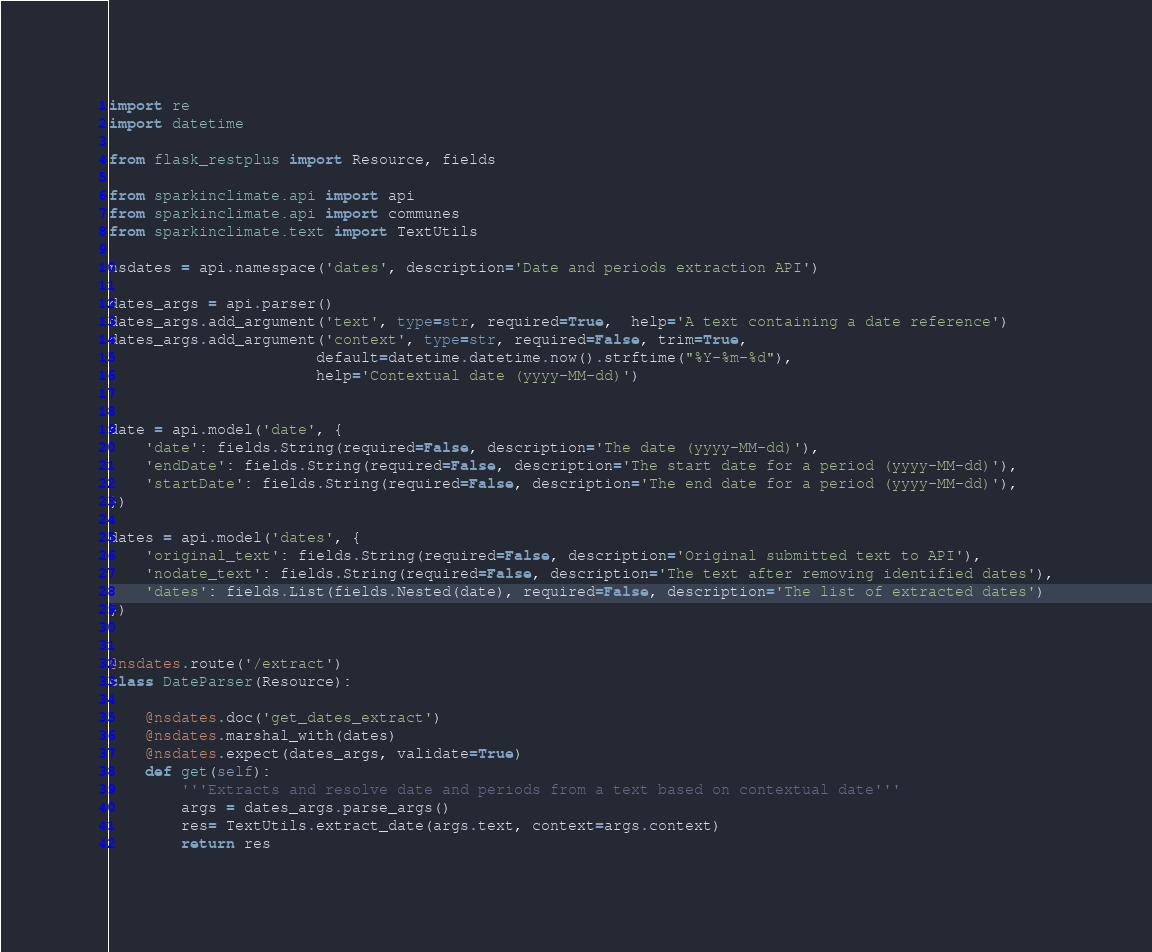<code> <loc_0><loc_0><loc_500><loc_500><_Python_>import re
import datetime

from flask_restplus import Resource, fields

from sparkinclimate.api import api
from sparkinclimate.api import communes
from sparkinclimate.text import TextUtils

nsdates = api.namespace('dates', description='Date and periods extraction API')

dates_args = api.parser()
dates_args.add_argument('text', type=str, required=True,  help='A text containing a date reference')
dates_args.add_argument('context', type=str, required=False, trim=True,
                       default=datetime.datetime.now().strftime("%Y-%m-%d"),
                       help='Contextual date (yyyy-MM-dd)')


date = api.model('date', {
    'date': fields.String(required=False, description='The date (yyyy-MM-dd)'),
    'endDate': fields.String(required=False, description='The start date for a period (yyyy-MM-dd)'),
    'startDate': fields.String(required=False, description='The end date for a period (yyyy-MM-dd)'),
})

dates = api.model('dates', {
    'original_text': fields.String(required=False, description='Original submitted text to API'),
    'nodate_text': fields.String(required=False, description='The text after removing identified dates'),
    'dates': fields.List(fields.Nested(date), required=False, description='The list of extracted dates')
})


@nsdates.route('/extract')
class DateParser(Resource):

    @nsdates.doc('get_dates_extract')
    @nsdates.marshal_with(dates)
    @nsdates.expect(dates_args, validate=True)
    def get(self):
        '''Extracts and resolve date and periods from a text based on contextual date'''
        args = dates_args.parse_args()
        res= TextUtils.extract_date(args.text, context=args.context) 
        return res

</code> 